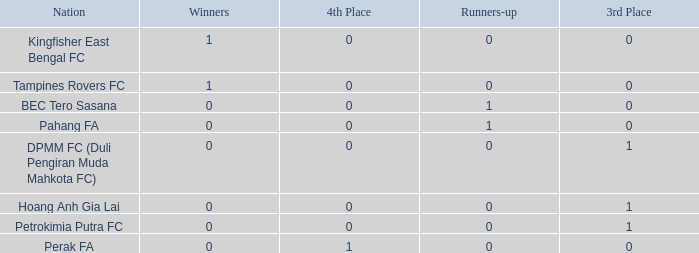Name the average 3rd place with winners of 0, 4th place of 0 and nation of pahang fa 0.0. 